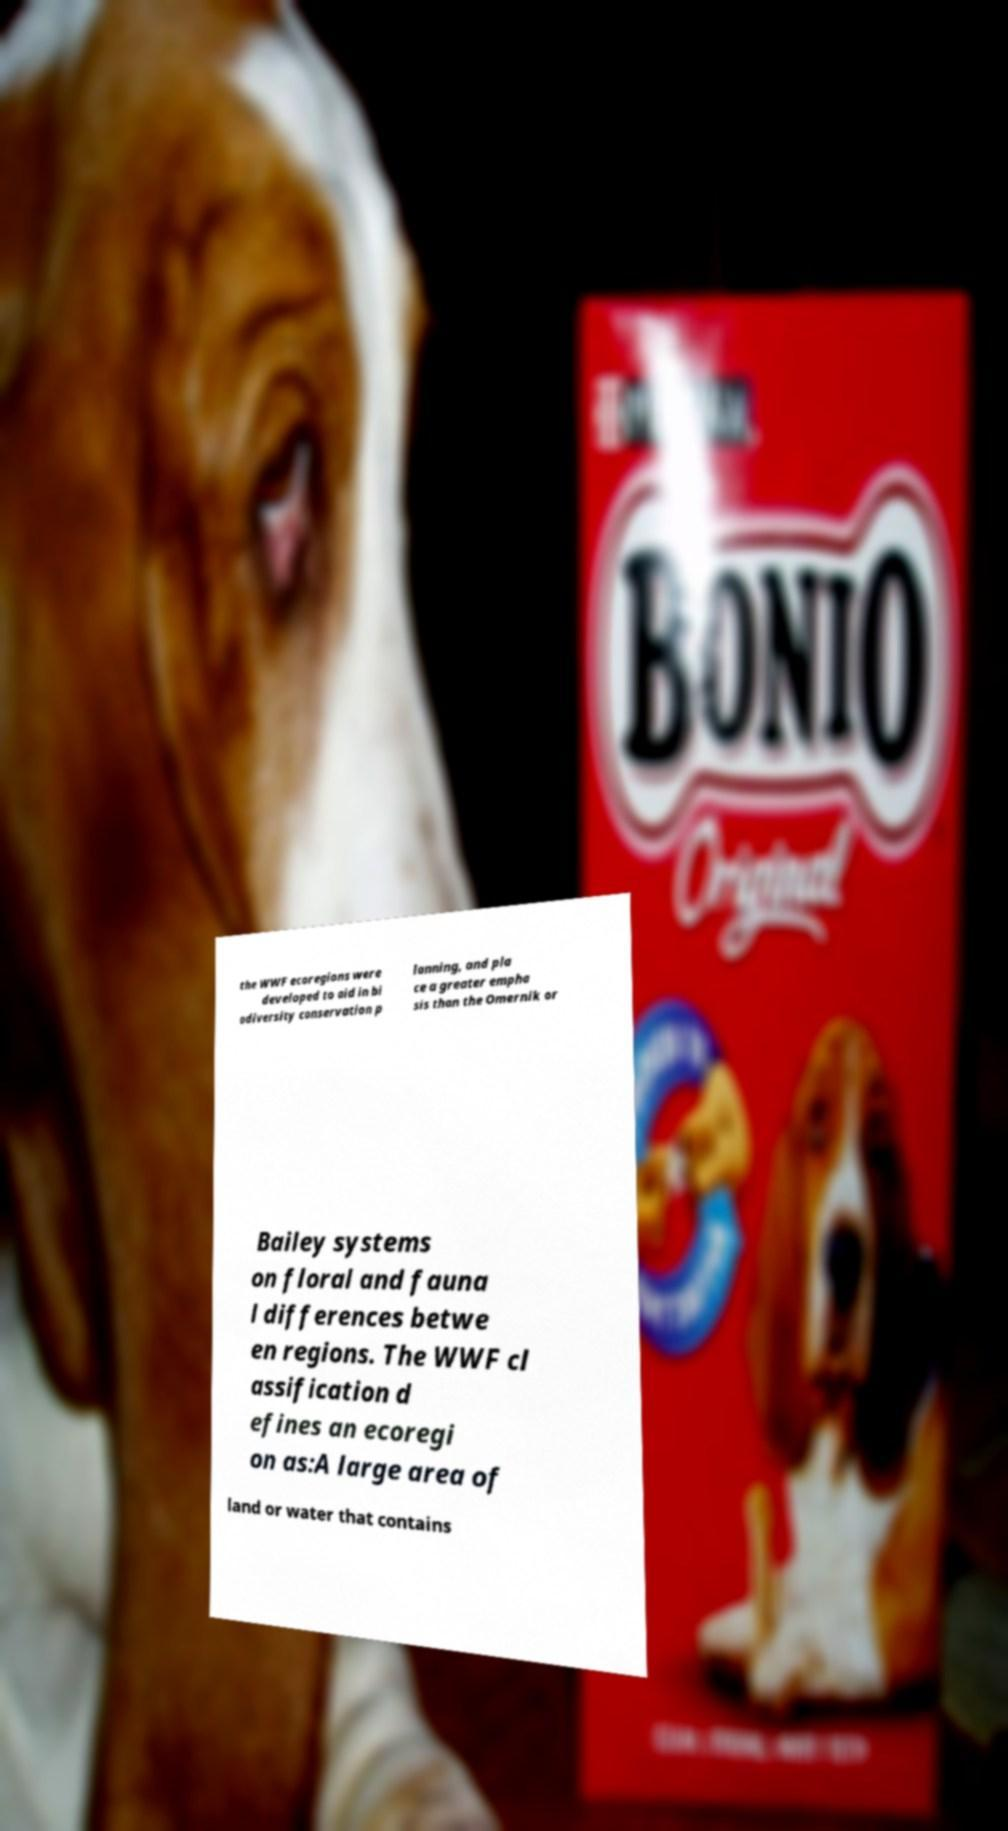Can you read and provide the text displayed in the image?This photo seems to have some interesting text. Can you extract and type it out for me? the WWF ecoregions were developed to aid in bi odiversity conservation p lanning, and pla ce a greater empha sis than the Omernik or Bailey systems on floral and fauna l differences betwe en regions. The WWF cl assification d efines an ecoregi on as:A large area of land or water that contains 